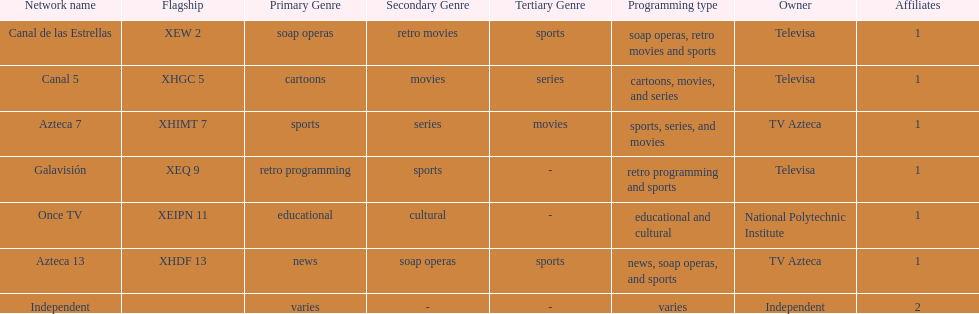How many networks does televisa own? 3. 